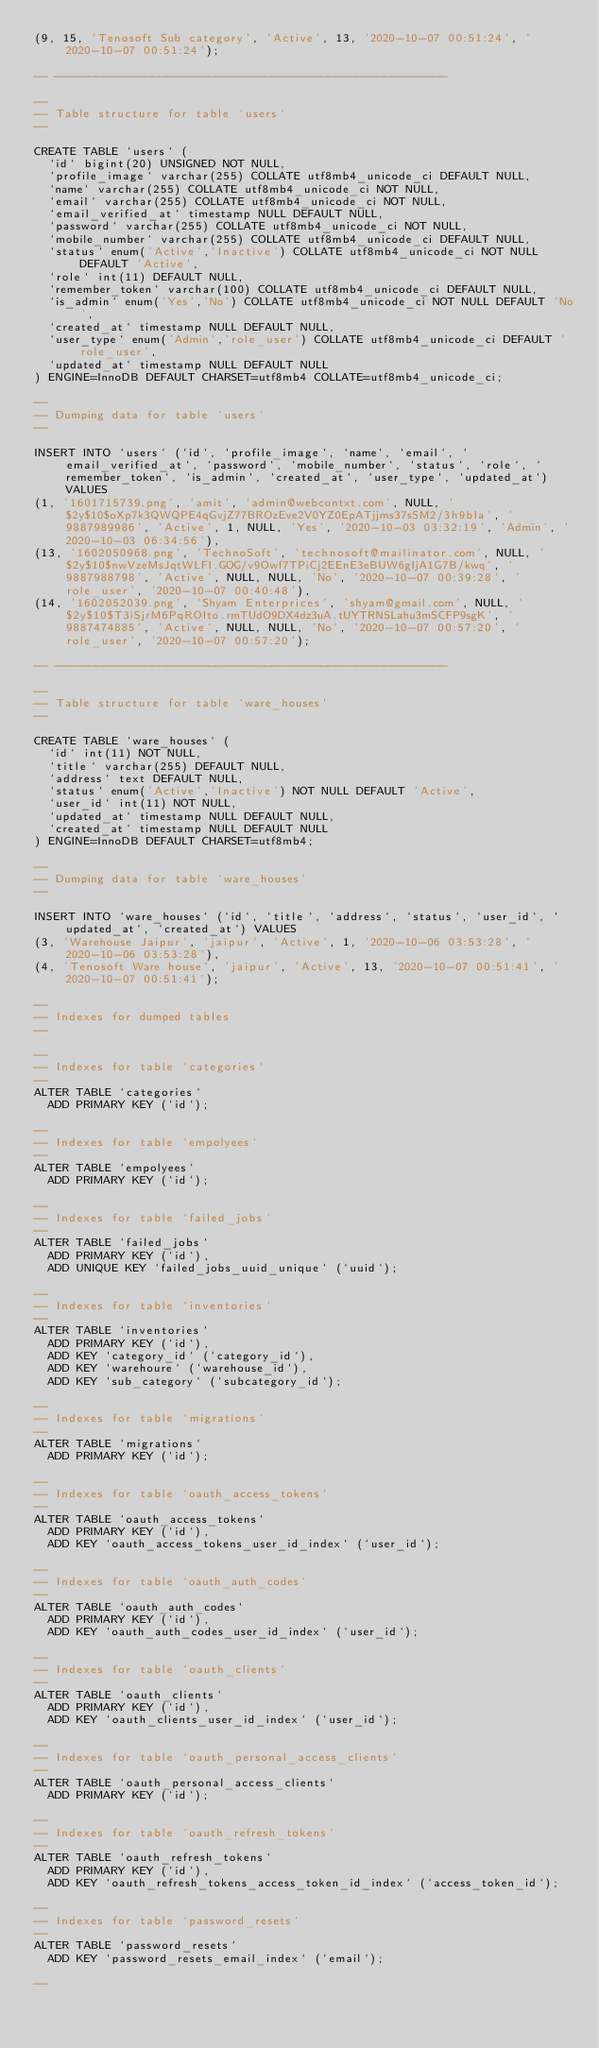Convert code to text. <code><loc_0><loc_0><loc_500><loc_500><_SQL_>(9, 15, 'Tenosoft Sub category', 'Active', 13, '2020-10-07 00:51:24', '2020-10-07 00:51:24');

-- --------------------------------------------------------

--
-- Table structure for table `users`
--

CREATE TABLE `users` (
  `id` bigint(20) UNSIGNED NOT NULL,
  `profile_image` varchar(255) COLLATE utf8mb4_unicode_ci DEFAULT NULL,
  `name` varchar(255) COLLATE utf8mb4_unicode_ci NOT NULL,
  `email` varchar(255) COLLATE utf8mb4_unicode_ci NOT NULL,
  `email_verified_at` timestamp NULL DEFAULT NULL,
  `password` varchar(255) COLLATE utf8mb4_unicode_ci NOT NULL,
  `mobile_number` varchar(255) COLLATE utf8mb4_unicode_ci DEFAULT NULL,
  `status` enum('Active','Inactive') COLLATE utf8mb4_unicode_ci NOT NULL DEFAULT 'Active',
  `role` int(11) DEFAULT NULL,
  `remember_token` varchar(100) COLLATE utf8mb4_unicode_ci DEFAULT NULL,
  `is_admin` enum('Yes','No') COLLATE utf8mb4_unicode_ci NOT NULL DEFAULT 'No',
  `created_at` timestamp NULL DEFAULT NULL,
  `user_type` enum('Admin','role_user') COLLATE utf8mb4_unicode_ci DEFAULT 'role_user',
  `updated_at` timestamp NULL DEFAULT NULL
) ENGINE=InnoDB DEFAULT CHARSET=utf8mb4 COLLATE=utf8mb4_unicode_ci;

--
-- Dumping data for table `users`
--

INSERT INTO `users` (`id`, `profile_image`, `name`, `email`, `email_verified_at`, `password`, `mobile_number`, `status`, `role`, `remember_token`, `is_admin`, `created_at`, `user_type`, `updated_at`) VALUES
(1, '1601715739.png', 'amit', 'admin@webcontxt.com', NULL, '$2y$10$oXp7k3QWQPE4qGvjZ77BROzEve2V0YZ0EpATjjms37sSM2/3h9bIa', '9887989986', 'Active', 1, NULL, 'Yes', '2020-10-03 03:32:19', 'Admin', '2020-10-03 06:34:56'),
(13, '1602050968.png', 'TechnoSoft', 'technosoft@mailinator.com', NULL, '$2y$10$nwVzeMsJqtWLFI.GOG/v9Owf7TPiCj2EEnE3eBUW6gIjA1G7B/kwq', '9887988798', 'Active', NULL, NULL, 'No', '2020-10-07 00:39:28', 'role_user', '2020-10-07 00:40:48'),
(14, '1602052039.png', 'Shyam Enterprices', 'shyam@gmail.com', NULL, '$2y$10$T3iSjrM6PqROIto.rmTUdO9DX4dz3uA.tUYTRNSLahu3mSCFP9sgK', '9887474885', 'Active', NULL, NULL, 'No', '2020-10-07 00:57:20', 'role_user', '2020-10-07 00:57:20');

-- --------------------------------------------------------

--
-- Table structure for table `ware_houses`
--

CREATE TABLE `ware_houses` (
  `id` int(11) NOT NULL,
  `title` varchar(255) DEFAULT NULL,
  `address` text DEFAULT NULL,
  `status` enum('Active','Inactive') NOT NULL DEFAULT 'Active',
  `user_id` int(11) NOT NULL,
  `updated_at` timestamp NULL DEFAULT NULL,
  `created_at` timestamp NULL DEFAULT NULL
) ENGINE=InnoDB DEFAULT CHARSET=utf8mb4;

--
-- Dumping data for table `ware_houses`
--

INSERT INTO `ware_houses` (`id`, `title`, `address`, `status`, `user_id`, `updated_at`, `created_at`) VALUES
(3, 'Warehouse Jaipur', 'jaipur', 'Active', 1, '2020-10-06 03:53:28', '2020-10-06 03:53:28'),
(4, 'Tenosoft Ware house', 'jaipur', 'Active', 13, '2020-10-07 00:51:41', '2020-10-07 00:51:41');

--
-- Indexes for dumped tables
--

--
-- Indexes for table `categories`
--
ALTER TABLE `categories`
  ADD PRIMARY KEY (`id`);

--
-- Indexes for table `empolyees`
--
ALTER TABLE `empolyees`
  ADD PRIMARY KEY (`id`);

--
-- Indexes for table `failed_jobs`
--
ALTER TABLE `failed_jobs`
  ADD PRIMARY KEY (`id`),
  ADD UNIQUE KEY `failed_jobs_uuid_unique` (`uuid`);

--
-- Indexes for table `inventories`
--
ALTER TABLE `inventories`
  ADD PRIMARY KEY (`id`),
  ADD KEY `category_id` (`category_id`),
  ADD KEY `warehoure` (`warehouse_id`),
  ADD KEY `sub_category` (`subcategory_id`);

--
-- Indexes for table `migrations`
--
ALTER TABLE `migrations`
  ADD PRIMARY KEY (`id`);

--
-- Indexes for table `oauth_access_tokens`
--
ALTER TABLE `oauth_access_tokens`
  ADD PRIMARY KEY (`id`),
  ADD KEY `oauth_access_tokens_user_id_index` (`user_id`);

--
-- Indexes for table `oauth_auth_codes`
--
ALTER TABLE `oauth_auth_codes`
  ADD PRIMARY KEY (`id`),
  ADD KEY `oauth_auth_codes_user_id_index` (`user_id`);

--
-- Indexes for table `oauth_clients`
--
ALTER TABLE `oauth_clients`
  ADD PRIMARY KEY (`id`),
  ADD KEY `oauth_clients_user_id_index` (`user_id`);

--
-- Indexes for table `oauth_personal_access_clients`
--
ALTER TABLE `oauth_personal_access_clients`
  ADD PRIMARY KEY (`id`);

--
-- Indexes for table `oauth_refresh_tokens`
--
ALTER TABLE `oauth_refresh_tokens`
  ADD PRIMARY KEY (`id`),
  ADD KEY `oauth_refresh_tokens_access_token_id_index` (`access_token_id`);

--
-- Indexes for table `password_resets`
--
ALTER TABLE `password_resets`
  ADD KEY `password_resets_email_index` (`email`);

--</code> 